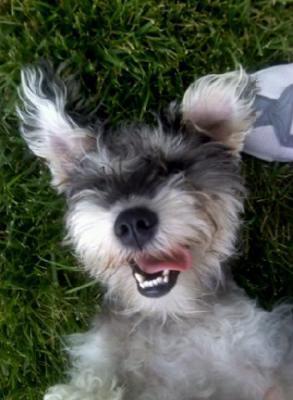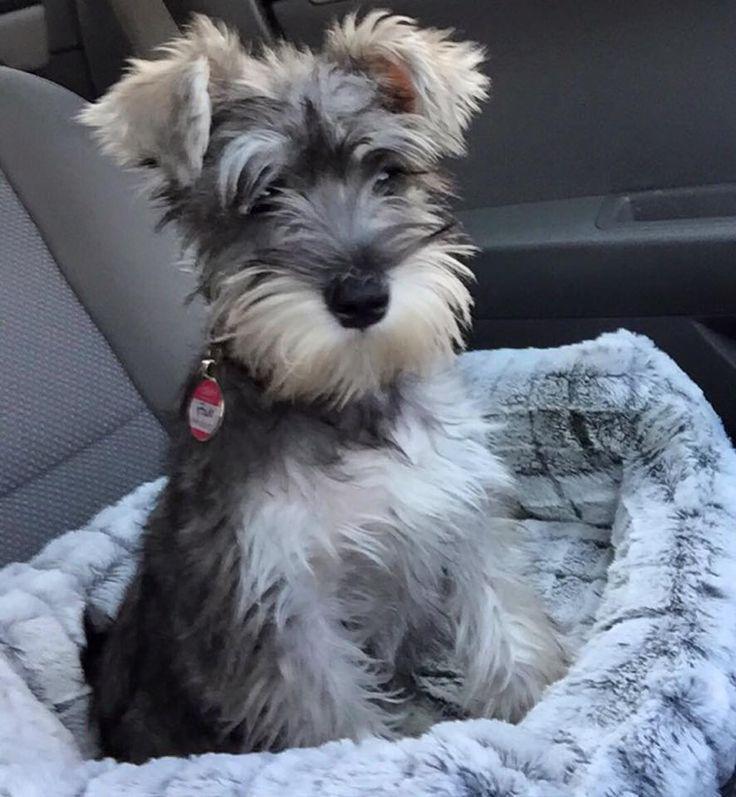The first image is the image on the left, the second image is the image on the right. Evaluate the accuracy of this statement regarding the images: "A dog in one image is mostly black with light colored bushy eyebrows and a matching light-colored beard.". Is it true? Answer yes or no. No. The first image is the image on the left, the second image is the image on the right. Analyze the images presented: Is the assertion "Right image shows at least one schnauzer dog sitting in a car." valid? Answer yes or no. Yes. 